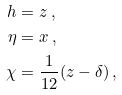<formula> <loc_0><loc_0><loc_500><loc_500>h & = z \ , \\ \eta & = x \ , \\ \chi & = \frac { 1 } { 1 2 } ( z - \delta ) \ ,</formula> 